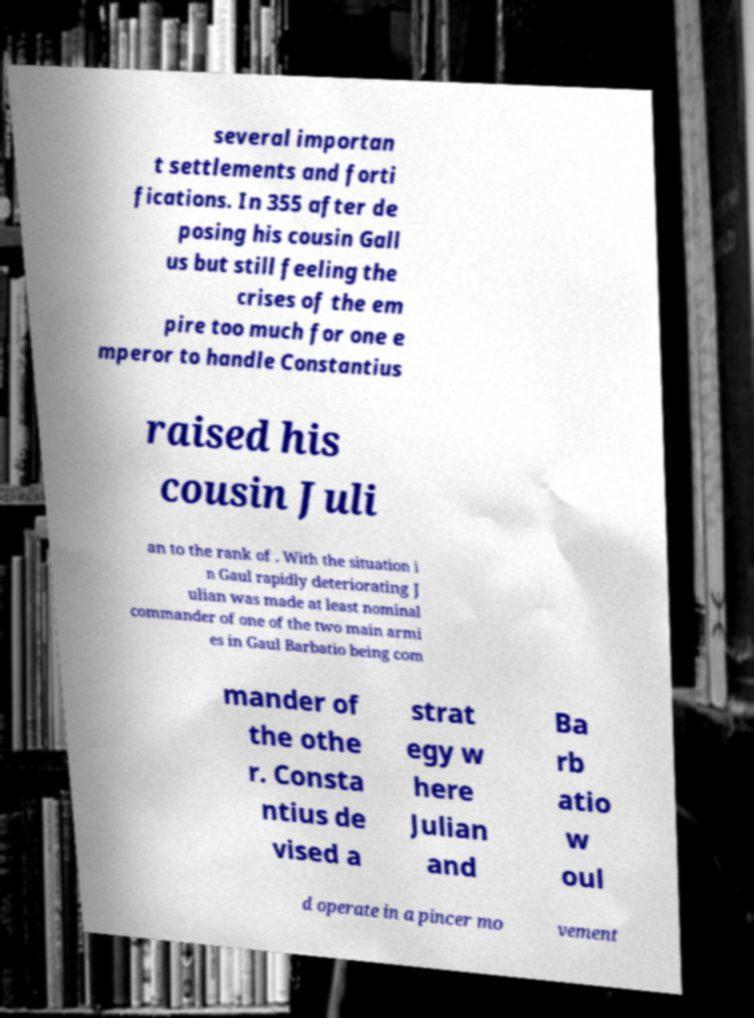Please identify and transcribe the text found in this image. several importan t settlements and forti fications. In 355 after de posing his cousin Gall us but still feeling the crises of the em pire too much for one e mperor to handle Constantius raised his cousin Juli an to the rank of . With the situation i n Gaul rapidly deteriorating J ulian was made at least nominal commander of one of the two main armi es in Gaul Barbatio being com mander of the othe r. Consta ntius de vised a strat egy w here Julian and Ba rb atio w oul d operate in a pincer mo vement 